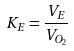<formula> <loc_0><loc_0><loc_500><loc_500>K _ { E } = \frac { V _ { E } } { V _ { O _ { 2 } } }</formula> 